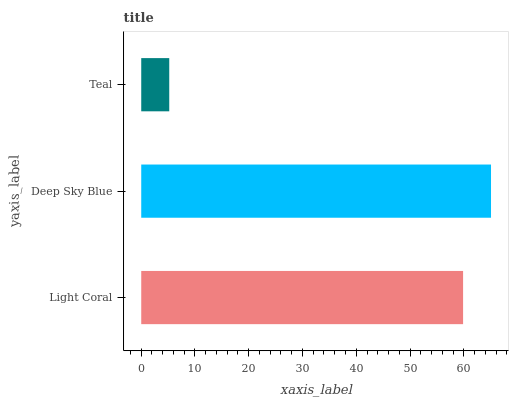Is Teal the minimum?
Answer yes or no. Yes. Is Deep Sky Blue the maximum?
Answer yes or no. Yes. Is Deep Sky Blue the minimum?
Answer yes or no. No. Is Teal the maximum?
Answer yes or no. No. Is Deep Sky Blue greater than Teal?
Answer yes or no. Yes. Is Teal less than Deep Sky Blue?
Answer yes or no. Yes. Is Teal greater than Deep Sky Blue?
Answer yes or no. No. Is Deep Sky Blue less than Teal?
Answer yes or no. No. Is Light Coral the high median?
Answer yes or no. Yes. Is Light Coral the low median?
Answer yes or no. Yes. Is Deep Sky Blue the high median?
Answer yes or no. No. Is Deep Sky Blue the low median?
Answer yes or no. No. 